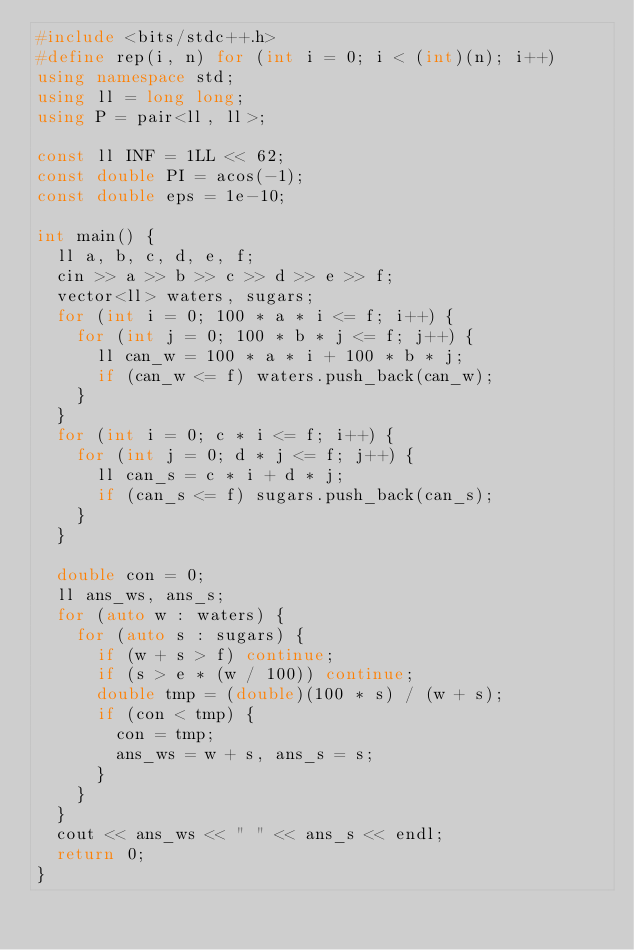Convert code to text. <code><loc_0><loc_0><loc_500><loc_500><_C++_>#include <bits/stdc++.h>
#define rep(i, n) for (int i = 0; i < (int)(n); i++)
using namespace std;
using ll = long long;
using P = pair<ll, ll>;

const ll INF = 1LL << 62;
const double PI = acos(-1);
const double eps = 1e-10;

int main() {
  ll a, b, c, d, e, f;
  cin >> a >> b >> c >> d >> e >> f;
  vector<ll> waters, sugars;
  for (int i = 0; 100 * a * i <= f; i++) {
    for (int j = 0; 100 * b * j <= f; j++) {
      ll can_w = 100 * a * i + 100 * b * j;
      if (can_w <= f) waters.push_back(can_w);
    }
  }
  for (int i = 0; c * i <= f; i++) {
    for (int j = 0; d * j <= f; j++) {
      ll can_s = c * i + d * j;
      if (can_s <= f) sugars.push_back(can_s);
    }
  }

  double con = 0;
  ll ans_ws, ans_s;
  for (auto w : waters) {
    for (auto s : sugars) {
      if (w + s > f) continue;
      if (s > e * (w / 100)) continue;
      double tmp = (double)(100 * s) / (w + s);
      if (con < tmp) {
        con = tmp;
        ans_ws = w + s, ans_s = s;
      }
    }
  }
  cout << ans_ws << " " << ans_s << endl;
  return 0;
}
</code> 